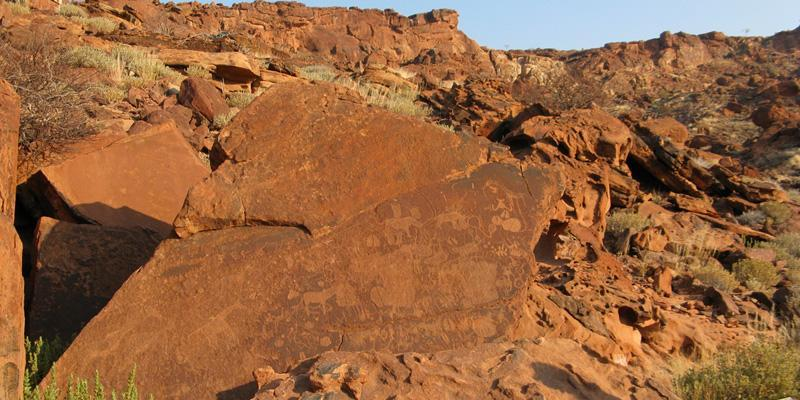Can you discuss the significance of the location of these engravings within the landscape? The location of these engravings on large, visible rocks in an elevated area could indicate their importance as communal or ceremonial spots, serving both practical and ritualistic purposes. Positioned where they are, they likely served as landmarks or meeting points, which would be visible from a distance, adding to their utility and significance in the landscape. 